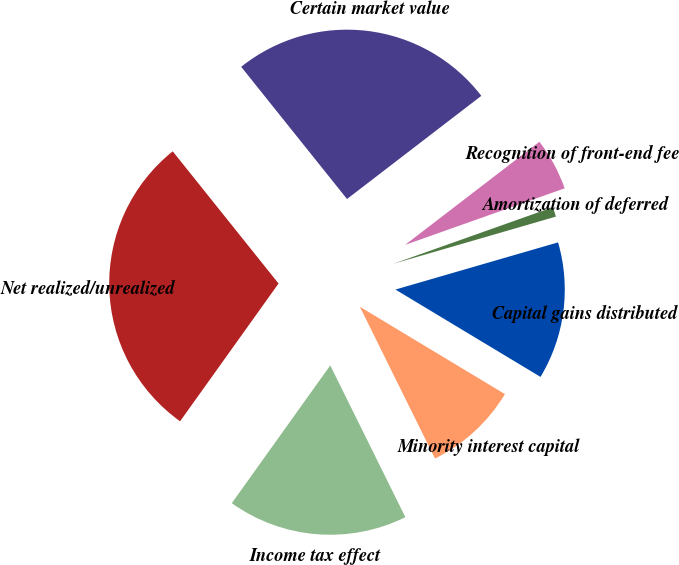<chart> <loc_0><loc_0><loc_500><loc_500><pie_chart><fcel>Net realized/unrealized<fcel>Certain market value<fcel>Recognition of front-end fee<fcel>Amortization of deferred<fcel>Capital gains distributed<fcel>Minority interest capital<fcel>Income tax effect<nl><fcel>29.38%<fcel>25.32%<fcel>5.0%<fcel>0.93%<fcel>13.12%<fcel>9.06%<fcel>17.19%<nl></chart> 